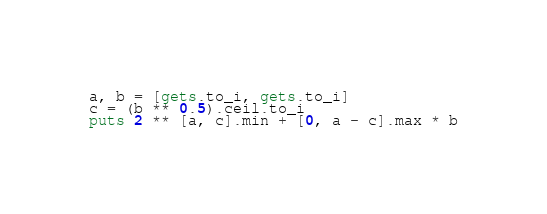<code> <loc_0><loc_0><loc_500><loc_500><_Ruby_>a, b = [gets.to_i, gets.to_i]
c = (b ** 0.5).ceil.to_i
puts 2 ** [a, c].min + [0, a - c].max * b
</code> 